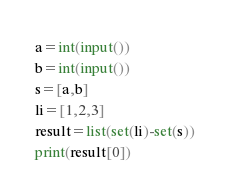<code> <loc_0><loc_0><loc_500><loc_500><_Python_>a=int(input())
b=int(input())
s=[a,b]
li=[1,2,3]
result=list(set(li)-set(s))
print(result[0])</code> 